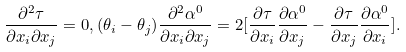Convert formula to latex. <formula><loc_0><loc_0><loc_500><loc_500>\frac { \partial ^ { 2 } \tau } { \partial x _ { i } \partial x _ { j } } = 0 , ( \theta _ { i } - \theta _ { j } ) \frac { \partial ^ { 2 } \alpha ^ { 0 } } { \partial x _ { i } \partial x _ { j } } = 2 [ \frac { \partial \tau } { \partial x _ { i } } \frac { \partial \alpha ^ { 0 } } { \partial x _ { j } } - \frac { \partial \tau } { \partial x _ { j } } \frac { \partial \alpha ^ { 0 } } { \partial x _ { i } } ] .</formula> 